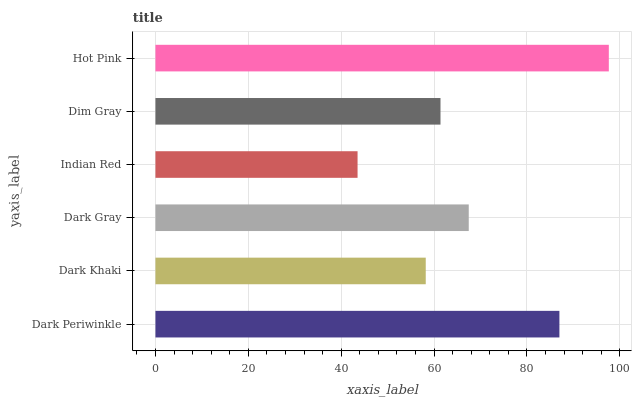Is Indian Red the minimum?
Answer yes or no. Yes. Is Hot Pink the maximum?
Answer yes or no. Yes. Is Dark Khaki the minimum?
Answer yes or no. No. Is Dark Khaki the maximum?
Answer yes or no. No. Is Dark Periwinkle greater than Dark Khaki?
Answer yes or no. Yes. Is Dark Khaki less than Dark Periwinkle?
Answer yes or no. Yes. Is Dark Khaki greater than Dark Periwinkle?
Answer yes or no. No. Is Dark Periwinkle less than Dark Khaki?
Answer yes or no. No. Is Dark Gray the high median?
Answer yes or no. Yes. Is Dim Gray the low median?
Answer yes or no. Yes. Is Dark Periwinkle the high median?
Answer yes or no. No. Is Indian Red the low median?
Answer yes or no. No. 